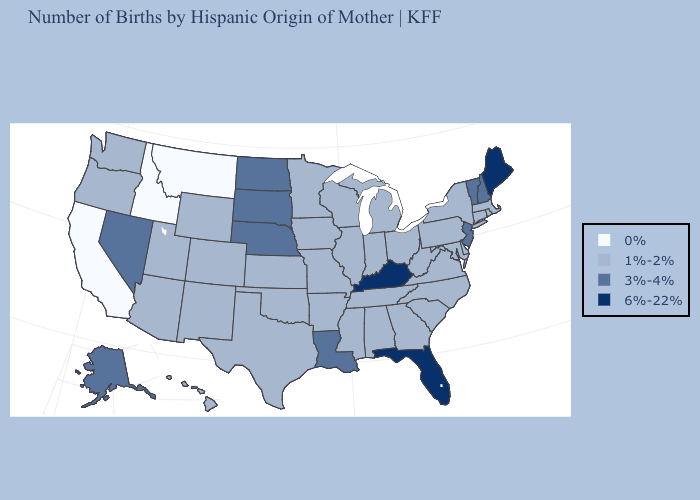Name the states that have a value in the range 1%-2%?
Short answer required. Alabama, Arizona, Arkansas, Colorado, Connecticut, Delaware, Georgia, Hawaii, Illinois, Indiana, Iowa, Kansas, Maryland, Massachusetts, Michigan, Minnesota, Mississippi, Missouri, New Mexico, New York, North Carolina, Ohio, Oklahoma, Oregon, Pennsylvania, Rhode Island, South Carolina, Tennessee, Texas, Utah, Virginia, Washington, West Virginia, Wisconsin, Wyoming. Which states hav the highest value in the South?
Give a very brief answer. Florida, Kentucky. What is the value of Iowa?
Concise answer only. 1%-2%. What is the lowest value in the Northeast?
Concise answer only. 1%-2%. Name the states that have a value in the range 3%-4%?
Write a very short answer. Alaska, Louisiana, Nebraska, Nevada, New Hampshire, New Jersey, North Dakota, South Dakota, Vermont. Does Maine have the highest value in the USA?
Be succinct. Yes. What is the value of Alaska?
Answer briefly. 3%-4%. How many symbols are there in the legend?
Quick response, please. 4. What is the highest value in the West ?
Answer briefly. 3%-4%. Which states hav the highest value in the South?
Quick response, please. Florida, Kentucky. Does New Hampshire have the same value as Virginia?
Keep it brief. No. Does Maine have the highest value in the Northeast?
Answer briefly. Yes. Does Virginia have the lowest value in the South?
Keep it brief. Yes. Which states have the highest value in the USA?
Quick response, please. Florida, Kentucky, Maine. Name the states that have a value in the range 1%-2%?
Answer briefly. Alabama, Arizona, Arkansas, Colorado, Connecticut, Delaware, Georgia, Hawaii, Illinois, Indiana, Iowa, Kansas, Maryland, Massachusetts, Michigan, Minnesota, Mississippi, Missouri, New Mexico, New York, North Carolina, Ohio, Oklahoma, Oregon, Pennsylvania, Rhode Island, South Carolina, Tennessee, Texas, Utah, Virginia, Washington, West Virginia, Wisconsin, Wyoming. 